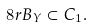Convert formula to latex. <formula><loc_0><loc_0><loc_500><loc_500>8 r B _ { Y } \subset C _ { 1 } .</formula> 